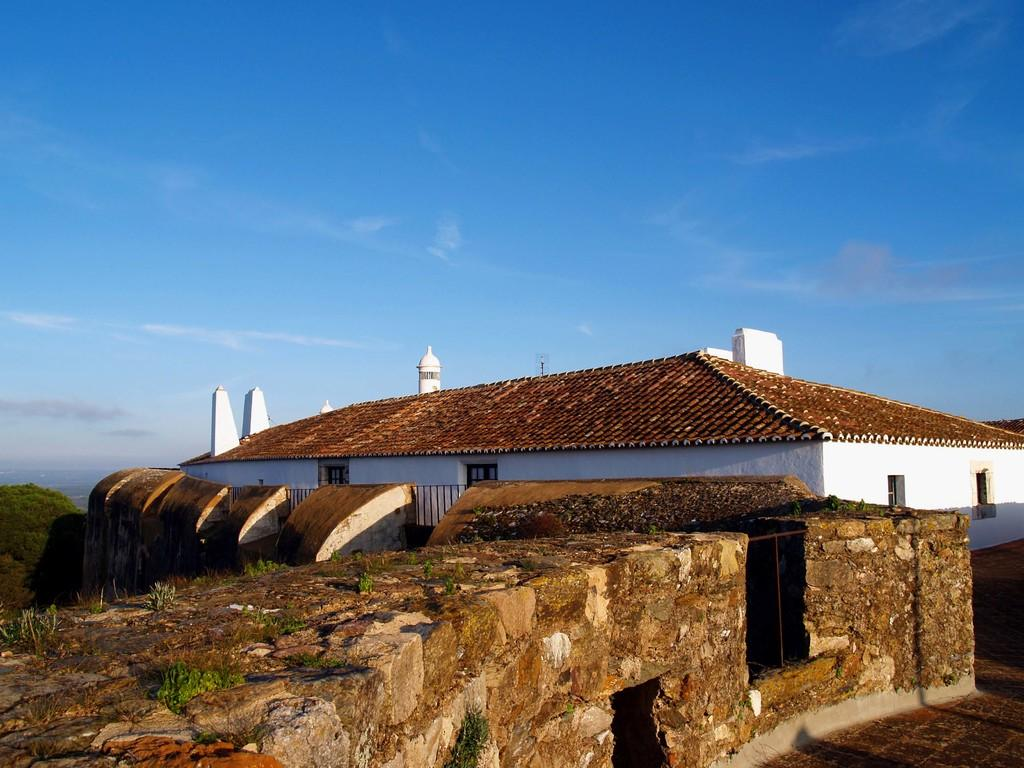What type of structure is visible in the image? There is a building in the image. What feature can be seen on the building? The building has windows. What is located at the left side of the image? There is a wall at the left side of the image. What type of vegetation is present in the image? There are trees in the image. What is the condition of the sky in the image? The sky is clear in the image. What type of loaf can be seen on the roof of the building in the image? There is no loaf present on the roof of the building in the image. What sound can be heard coming from the trees in the image? There is no sound present in the image, as it is a still photograph. 